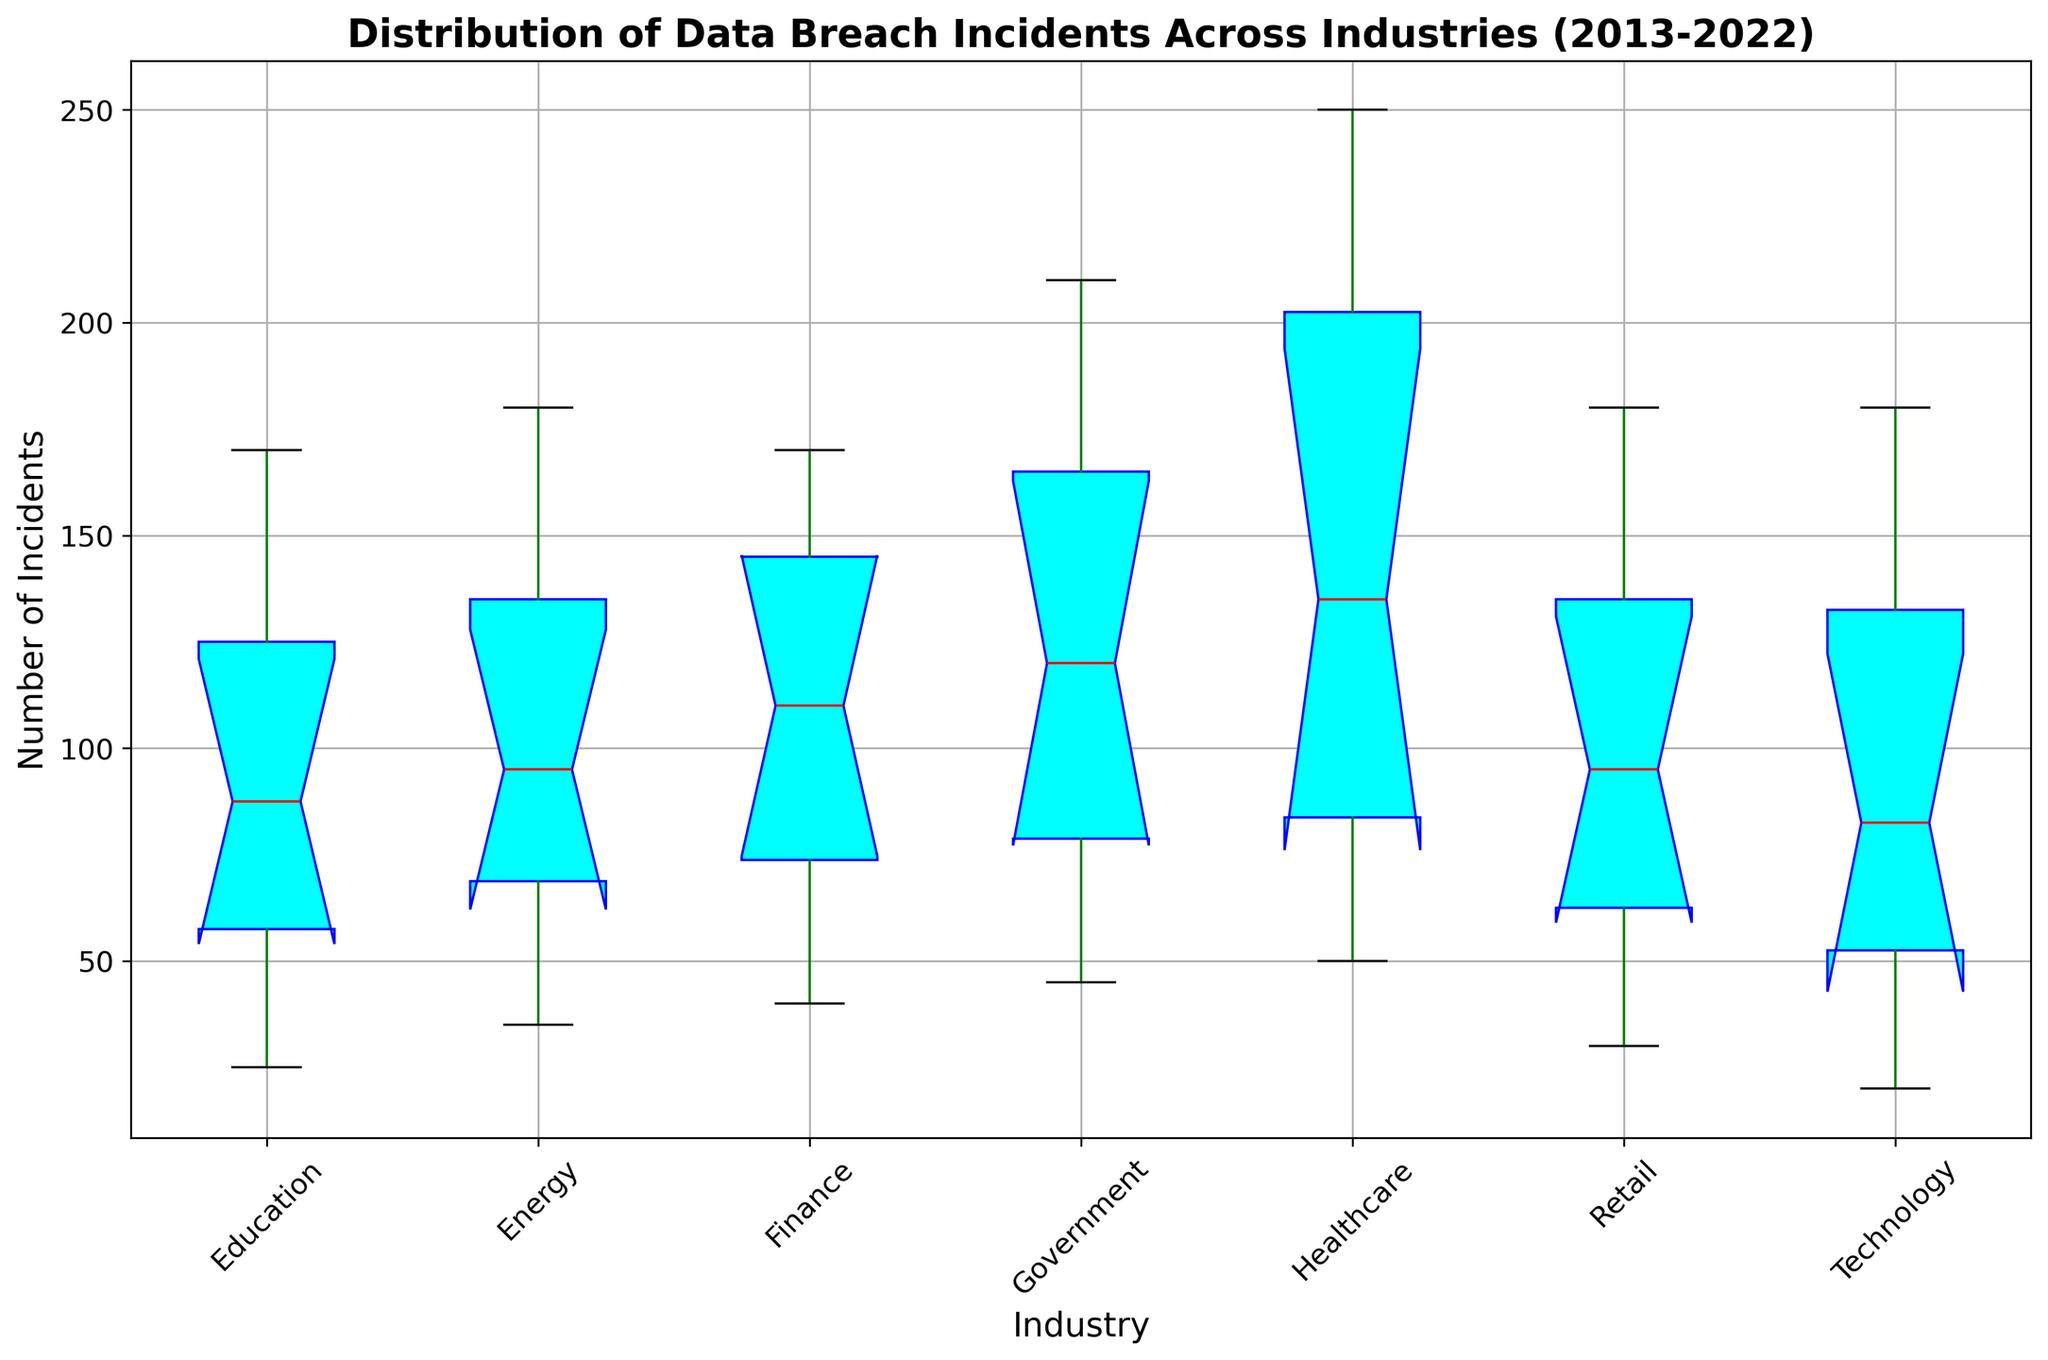What is the median number of incidents in the Finance industry? Locate the median line, which is marked in red within the box for the Finance industry. This horizontal line represents the median value.
Answer: 120 Which industry shows the highest maximum number of incidents? Compare the top whiskers of each box plot to identify the tallest one.
Answer: Healthcare How does the interquartile range (IQR) of the Government industry compare to that of the Education industry? The IQR is the height of the box itself, which is the distance between the first and third quartiles. Compare the heights of the boxes for both industries.
Answer: Government's IQR is larger Which industry has the smallest range of incidents? The range is the distance between the top and bottom whiskers. Locate the industry with the shortest overall whisker length.
Answer: Technology Is the median number of incidents in the Retail industry higher than in the Education industry? Compare the red median line in the Retail industry box to the red median line in the Education industry box.
Answer: Yes Identify any industries containing outliers and state how many are visible. Outliers are visualized as dots or stars outside the whiskers of a box plot. Count the distinct dots or stars.
Answer: No visible outliers Which industry has the highest 75th percentile of incidents? The 75th percentile is represented by the top boundary of the box. Identify the box with the highest top boundary.
Answer: Healthcare Does the median incident count for the Technology industry exceed 100? Locate the red median line within the Technology box and see if it extends above the 100 incidents mark on the y-axis.
Answer: Yes What is the approximate variance in the number of incidents for the Energy industry? While variance is not directly visualized, a wider spread between whiskers and more elongated box plots usually imply higher variance.
Answer: High variance Between the Healthcare and the Retail industries, which has a higher 25th percentile? The 25th percentile is marked by the bottom boundary of each box. Compare which boundary is higher between the two industries.
Answer: Healthcare 